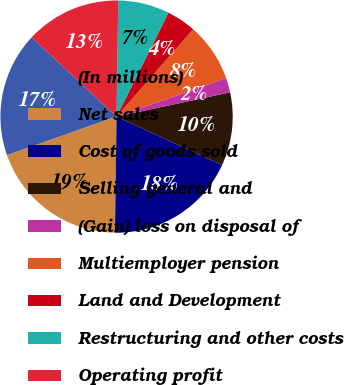Convert chart to OTSL. <chart><loc_0><loc_0><loc_500><loc_500><pie_chart><fcel>(In millions)<fcel>Net sales<fcel>Cost of goods sold<fcel>Selling general and<fcel>(Gain) loss on disposal of<fcel>Multiemployer pension<fcel>Land and Development<fcel>Restructuring and other costs<fcel>Operating profit<nl><fcel>17.35%<fcel>19.39%<fcel>18.37%<fcel>10.2%<fcel>2.04%<fcel>8.16%<fcel>4.08%<fcel>7.14%<fcel>13.27%<nl></chart> 